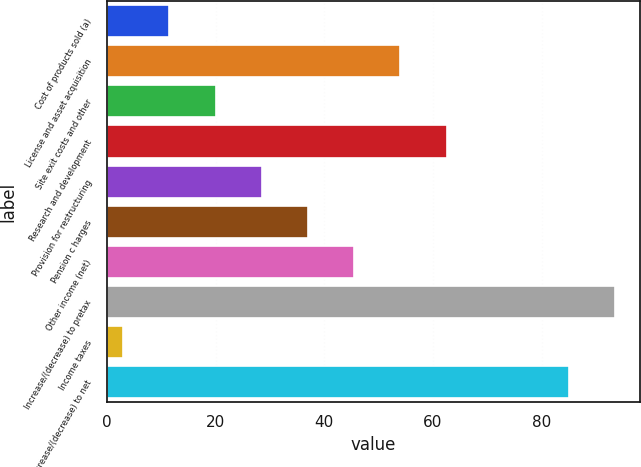Convert chart. <chart><loc_0><loc_0><loc_500><loc_500><bar_chart><fcel>Cost of products sold (a)<fcel>License and asset acquisition<fcel>Site exit costs and other<fcel>Research and development<fcel>Provision for restructuring<fcel>Pension c harges<fcel>Other income (net)<fcel>Increase/(decrease) to pretax<fcel>Income taxes<fcel>Increase/(decrease) to net<nl><fcel>11.5<fcel>54<fcel>20<fcel>62.5<fcel>28.5<fcel>37<fcel>45.5<fcel>93.5<fcel>3<fcel>85<nl></chart> 